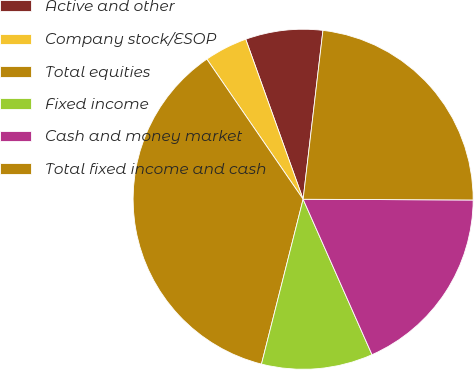Convert chart. <chart><loc_0><loc_0><loc_500><loc_500><pie_chart><fcel>Active and other<fcel>Company stock/ESOP<fcel>Total equities<fcel>Fixed income<fcel>Cash and money market<fcel>Total fixed income and cash<nl><fcel>7.34%<fcel>4.1%<fcel>36.48%<fcel>10.58%<fcel>18.29%<fcel>23.21%<nl></chart> 